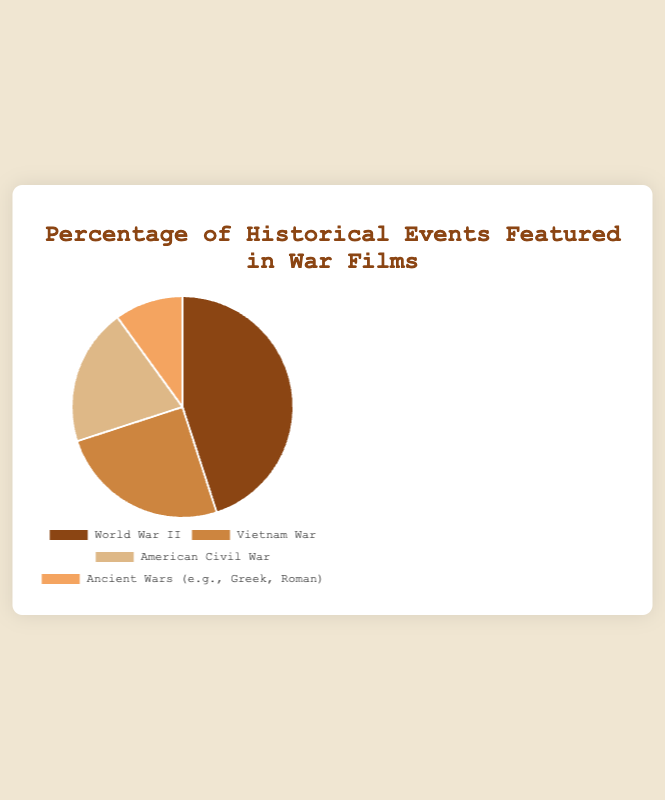What is the total percentage of films that feature either the Vietnam War or the American Civil War? Sum the percentages of films featuring the Vietnam War (25%) and the American Civil War (20%). The total percentage is 25% + 20% = 45%
Answer: 45% Which war has the smallest representation in war films? The Ancient Wars (e.g., Greek, Roman) have the smallest percentage at 10% compared to other events listed.
Answer: Ancient Wars (e.g., Greek, Roman) Is the representation of World War II in films greater than the combined representation of the Vietnam War and the American Civil War? The percentage of World War II is 45%. The combined percentage of the Vietnam War and the American Civil War is 25% + 20% = 45%. Since 45% (World War II) is equal to 45% (Vietnam War + American Civil War), the representation is not greater.
Answer: No How much more frequently are films made about World War II compared to films about Ancient Wars? Subtract the percentage of films about Ancient Wars (10%) from the percentage of films about World War II (45%). The difference is 45% - 10% = 35%.
Answer: 35% What is the average percentage of films featuring each historical event listed? Add all percentages: 45% (World War II) + 25% (Vietnam War) + 20% (American Civil War) + 10% (Ancient Wars) = 100%. Divide by the number of events, which is 4. The average is 100% / 4 = 25%.
Answer: 25% If you combine the percentages of films that feature historical events from either the American Civil War or Ancient Wars, does it exceed the percentage of films featuring World War II? The combined percentage of the American Civil War (20%) and Ancient Wars (10%) is 20% + 10% = 30%. Compared to the percentage of World War II (45%), 30% does not exceed 45%.
Answer: No How do the combined percentages of films from the Vietnam War and Ancient Wars compare to those of World War II? Add the percentages of the Vietnam War (25%) and Ancient Wars (10%), which totals 25% + 10% = 35%. Compare to World War II (45%). Since 35% is less than 45%, the combined total is less.
Answer: Less What color represents the Vietnam War in the chart? The Vietnam War is represented by the second color in the chart, which is described as a lighter brown (tan color).
Answer: Tan What percentage of films do not feature either World War II or Vietnam War? Combine the percentages for American Civil War (20%) and Ancient Wars (10%). The total is 20% + 10% = 30%.
Answer: 30% Among the four events, which two have the closest representation percentages, and what is the difference? Compare the percentages: World War II (45%), Vietnam War (25%), American Civil War (20%), and Ancient Wars (10%). The closest percentages are American Civil War (20%) and Ancient Wars (10%), with a difference of 20% - 10% = 10%.
Answer: American Civil War and Ancient Wars, 10% 